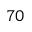Convert formula to latex. <formula><loc_0><loc_0><loc_500><loc_500>^ { 7 0 }</formula> 